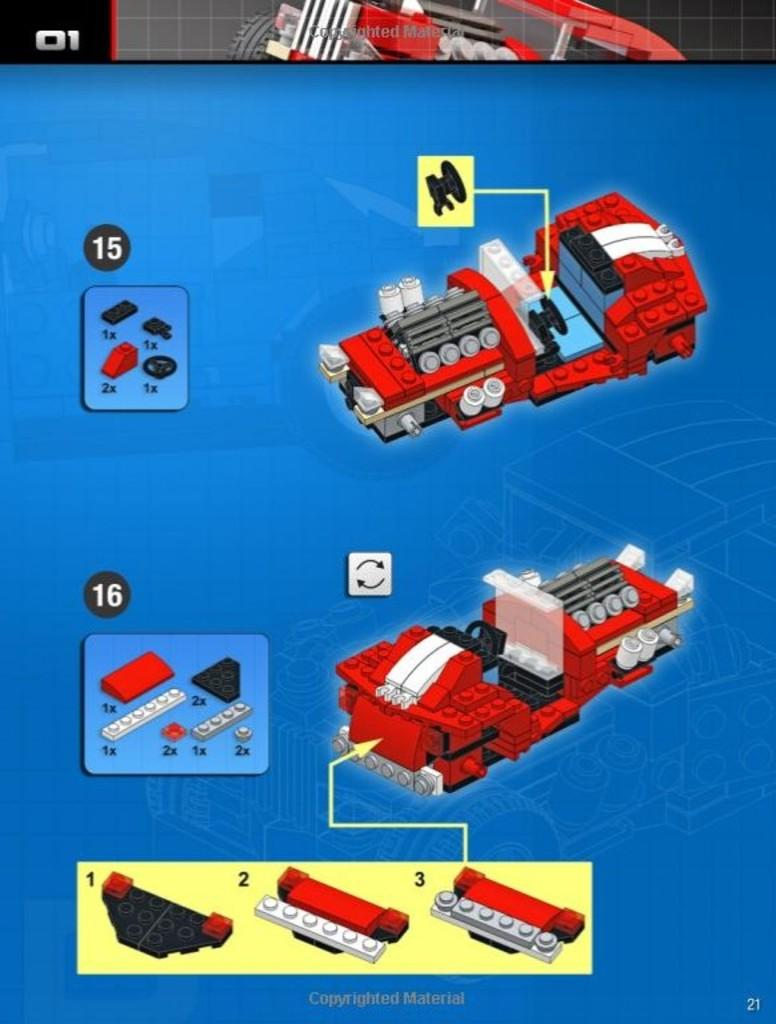What is the main subject of the image? The main subject of the image is a toy. What is written at the bottom of the image? There is text at the bottom of the image. How many members are in the group of people standing next to the toy in the image? There is no group of people present in the image; it only features a toy. What type of hydrant is visible in the image? There is no hydrant present in the image; it only features a toy. 